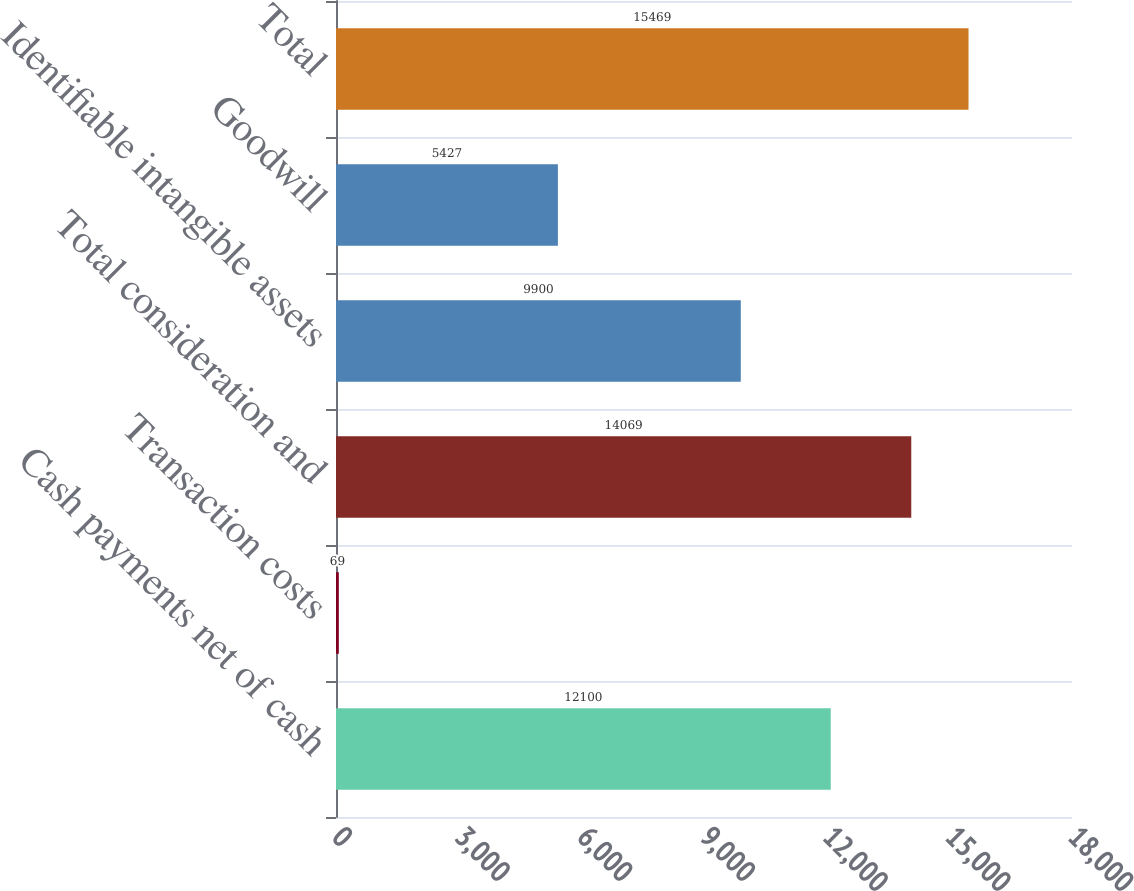Convert chart. <chart><loc_0><loc_0><loc_500><loc_500><bar_chart><fcel>Cash payments net of cash<fcel>Transaction costs<fcel>Total consideration and<fcel>Identifiable intangible assets<fcel>Goodwill<fcel>Total<nl><fcel>12100<fcel>69<fcel>14069<fcel>9900<fcel>5427<fcel>15469<nl></chart> 